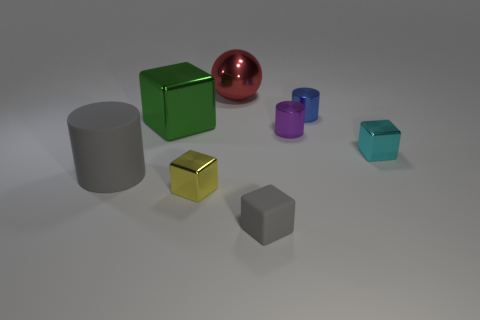Subtract all red blocks. Subtract all purple cylinders. How many blocks are left? 4 Add 2 brown rubber cylinders. How many objects exist? 10 Subtract all spheres. How many objects are left? 7 Add 5 green shiny objects. How many green shiny objects exist? 6 Subtract 0 blue balls. How many objects are left? 8 Subtract all cyan metal things. Subtract all tiny metallic cubes. How many objects are left? 5 Add 7 red metal objects. How many red metal objects are left? 8 